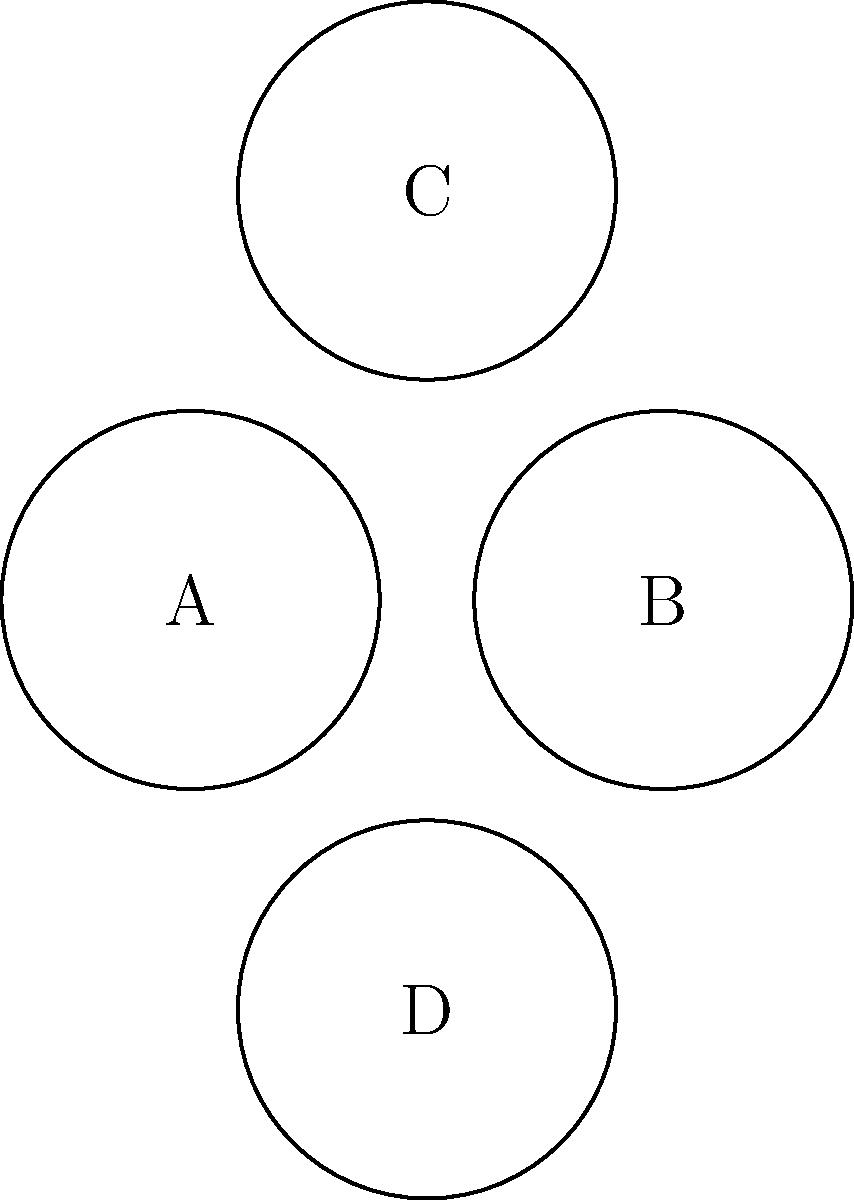In the collage of portraits above, which letter represents the image of Chip and Joanna Gaines, famous Baylor alumni known for their home renovation show "Fixer Upper"? To answer this question, we need to follow these steps:

1. Recall that Chip and Joanna Gaines are well-known Baylor University alumni.
2. Remember that they gained fame through their HGTV show "Fixer Upper."
3. Understand that as a former Baylor student, you would likely be familiar with their connection to the university.
4. Imagine that one of the portraits in the collage would depict the couple together, as they are often seen as a team.
5. In this hypothetical collage, assume that portrait B represents Chip and Joanna Gaines.

While the actual images are not provided in this diagram, in a real Visual Intelligence Test, you would need to recognize the Gaines couple from their portrait among other famous Baylor alumni.
Answer: B 